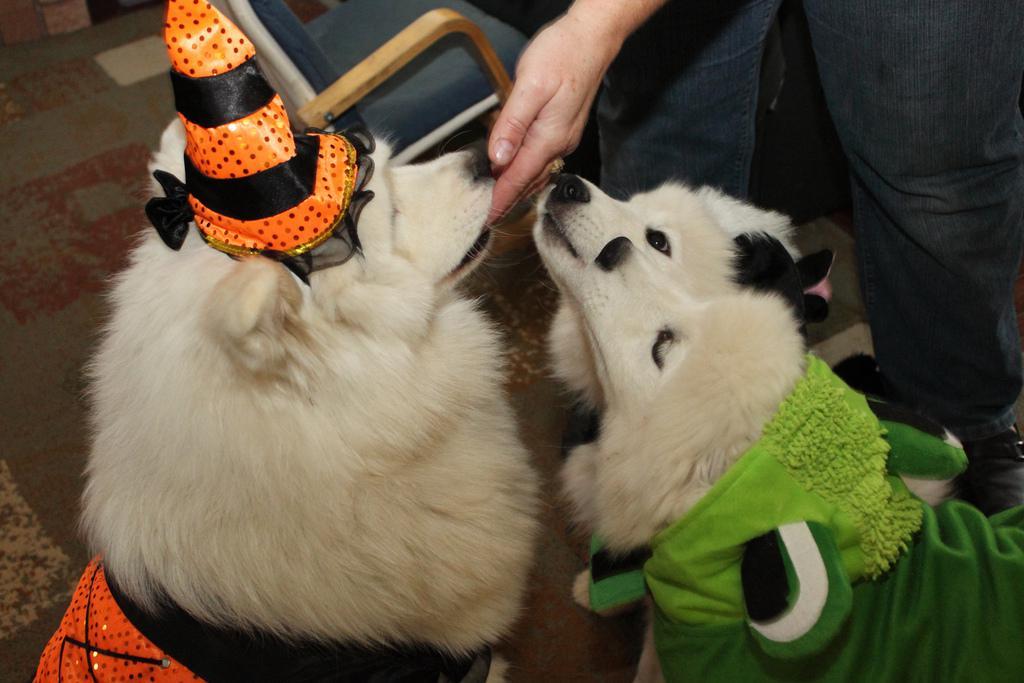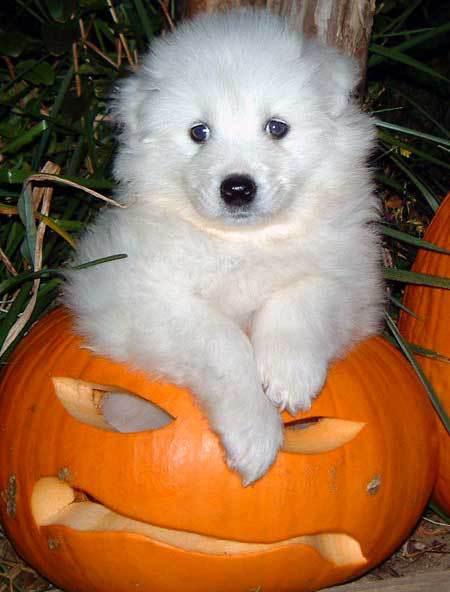The first image is the image on the left, the second image is the image on the right. Analyze the images presented: Is the assertion "A white dog is wearing an orange and black Halloween costume that has a matching hat." valid? Answer yes or no. Yes. The first image is the image on the left, the second image is the image on the right. Assess this claim about the two images: "at least one dog is dressed in costume". Correct or not? Answer yes or no. Yes. 